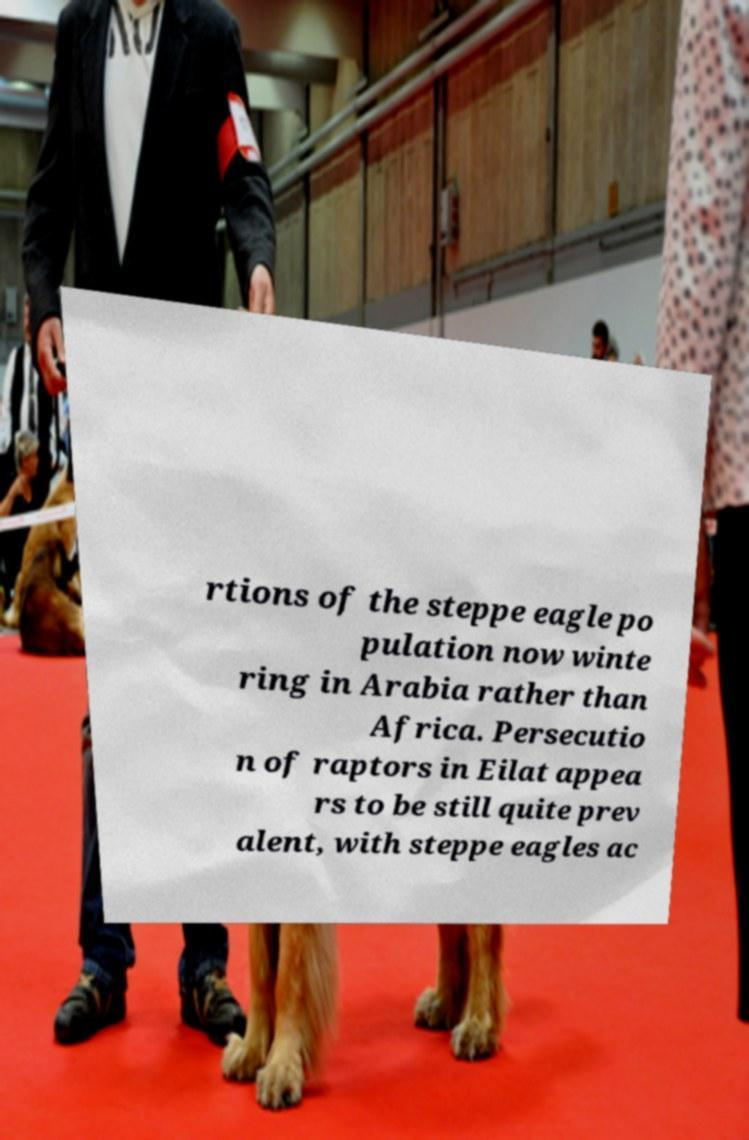Please read and relay the text visible in this image. What does it say? rtions of the steppe eagle po pulation now winte ring in Arabia rather than Africa. Persecutio n of raptors in Eilat appea rs to be still quite prev alent, with steppe eagles ac 